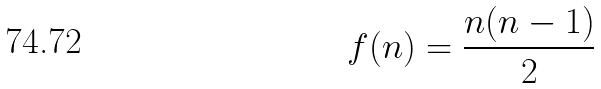Convert formula to latex. <formula><loc_0><loc_0><loc_500><loc_500>f ( n ) = \frac { n ( n - 1 ) } { 2 }</formula> 